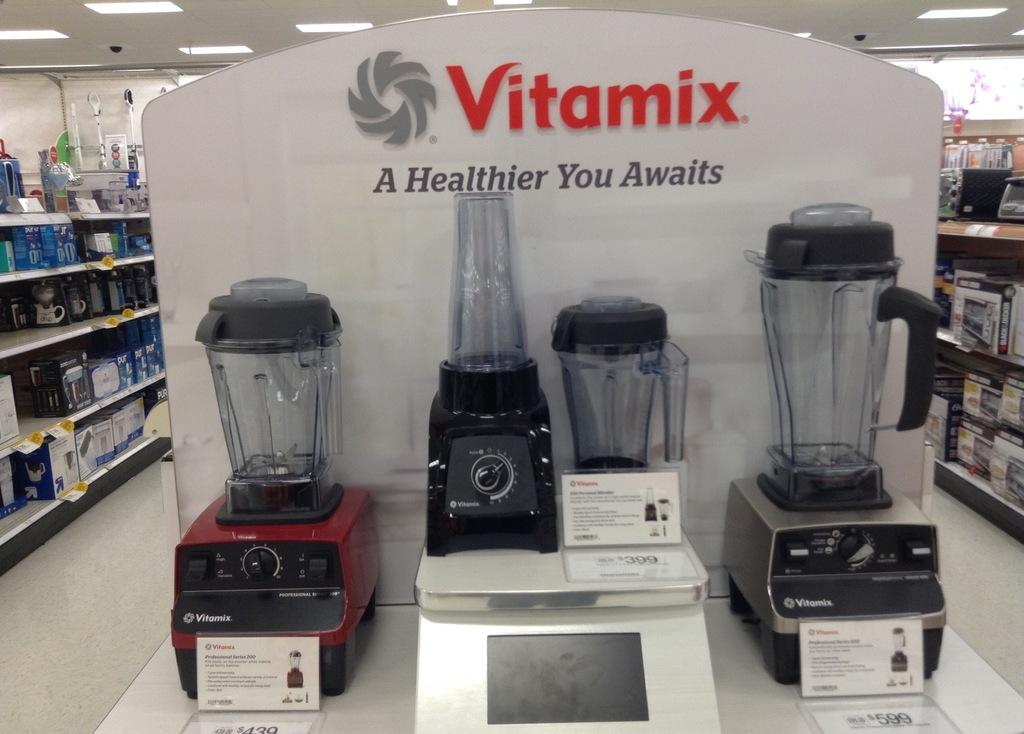<image>
Describe the image concisely. Several Vitamix blenders sit on display in a store 